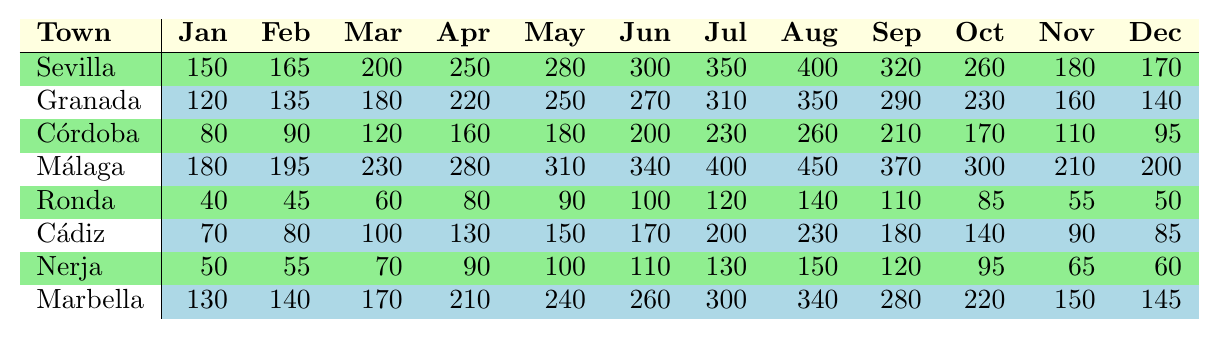What was the tourist footfall in September for Málaga? Referring to the table, the footfall for Málaga in September is listed as 370,000.
Answer: 370000 Which town had the lowest tourist footfall in December? Looking at the values in December, Ronda had the lowest footfall of 50,000.
Answer: Ronda What is the total number of tourists that visited Sevilla from January to April? Adding the values from January (150,000), February (165,000), March (200,000), and April (250,000) gives: 150000 + 165000 + 200000 + 250000 = 765000.
Answer: 765000 Did Cádiz experience more tourist footfall in June than Córdoba did in July? In June, Cádiz had 170,000 visitors and Córdoba had 230,000 in July. Since 170,000 is less than 230,000, the answer is no.
Answer: No What is the average monthly tourist footfall for Granada over the entire year? Summing all monthly footfalls for Granada (120000 + 135000 + 180000 + 220000 + 250000 + 270000 + 310000 + 350000 + 290000 + 230000 + 160000 + 140000 = 2,665,000) and dividing by 12 gives: 2665000 / 12 ≈ 222083.33. The average is approximately 222,083.
Answer: 222083 In which month did Marbella experience the highest tourist footfall? Looking through the data for Marbella, the highest value is in August with 340,000 tourists.
Answer: August What was the difference in tourist footfall between Ronda in July and Málaga in July? For Ronda in July, the footfall was 120,000, and for Málaga it was 400,000. The difference is 400,000 - 120,000 = 280,000.
Answer: 280000 Is the tourist footfall in Nerja for October higher than that of Córdoba for October? Nerja had 95,000 in October while Córdoba had 170,000. Since 95,000 is less than 170,000, the answer is no.
Answer: No What is the total tourist footfall for all towns in the month of May? Calculating the total for May: 280000 (Sevilla) + 250000 (Granada) + 180000 (Córdoba) + 310000 (Málaga) + 90000 (Ronda) + 150000 (Cádiz) + 100000 (Nerja) + 240000 (Marbella) = 1,540,000.
Answer: 1540000 Who had a higher footfall in August, Marbella or Sevilla? In August, Marbella had 340,000, and Sevilla had 400,000. Since 400,000 is greater than 340,000, Sevilla had a higher footfall.
Answer: Sevilla 